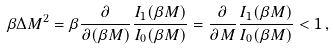Convert formula to latex. <formula><loc_0><loc_0><loc_500><loc_500>\beta \Delta M ^ { 2 } = \beta \frac { \partial } { \partial ( \beta M ) } \frac { I _ { 1 } ( \beta M ) } { I _ { 0 } ( \beta M ) } = \frac { \partial } { \partial M } \frac { I _ { 1 } ( \beta M ) } { I _ { 0 } ( \beta M ) } < 1 \, ,</formula> 